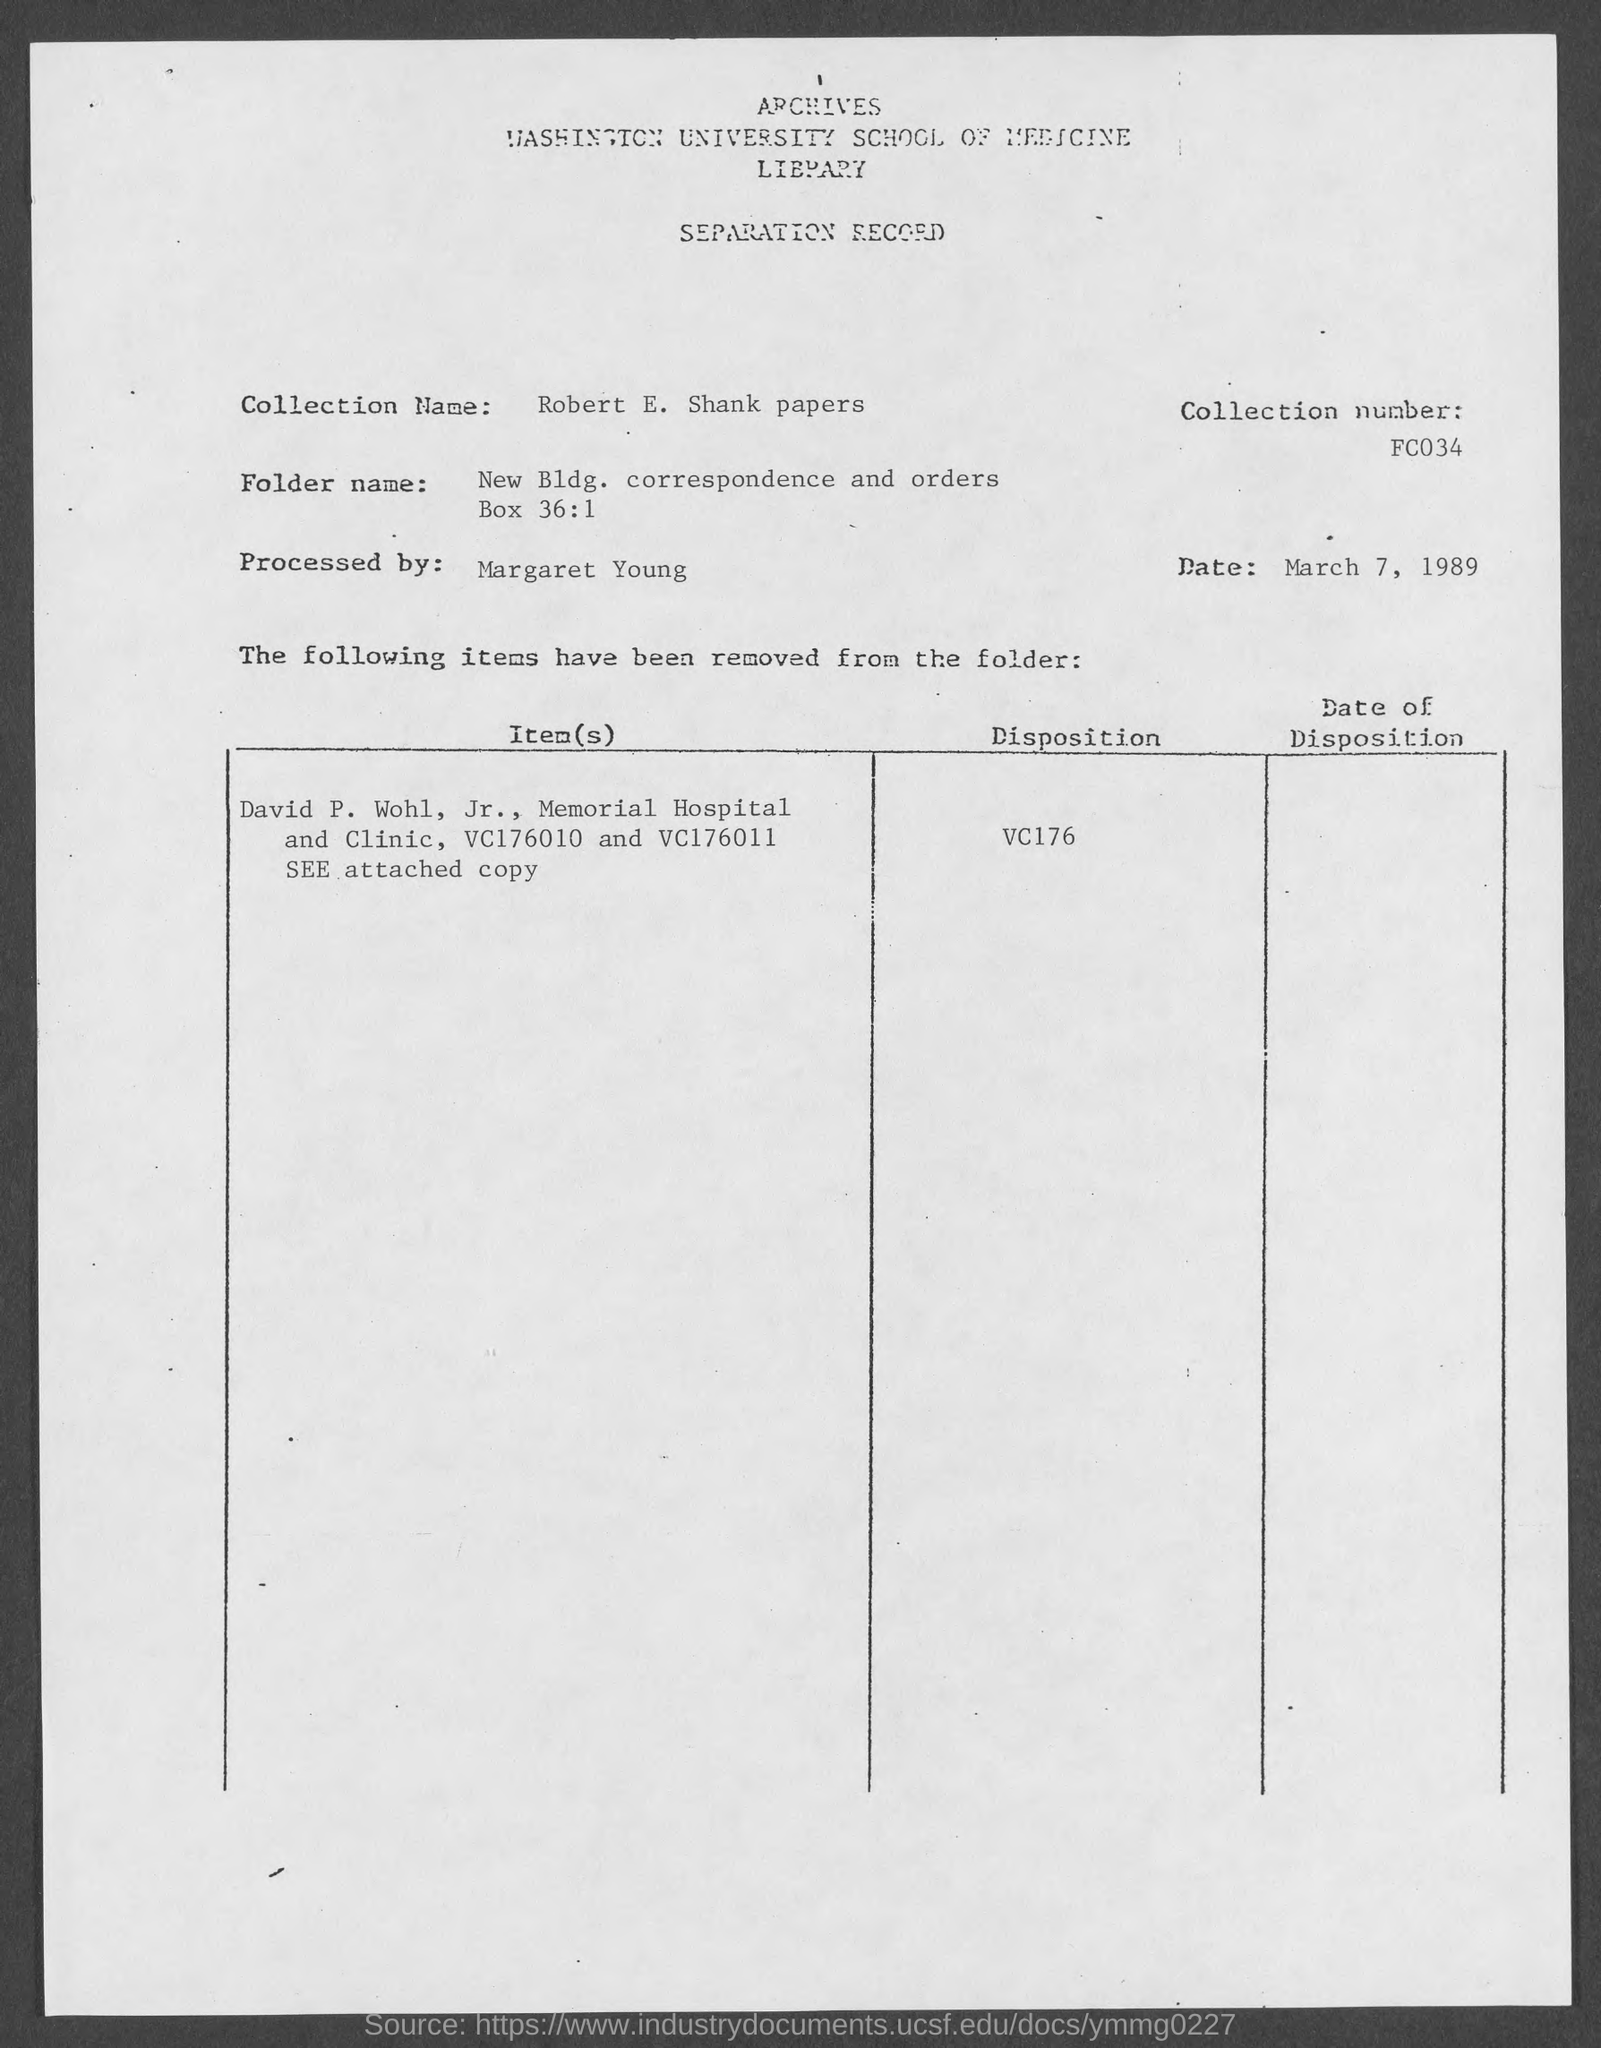What is the collection name given in the separation record?
Keep it short and to the point. Robert E. Shank papers. What is the collection number mentioned in the record?
Provide a succinct answer. FC034. What is the date mentioned in the separation record?
Keep it short and to the point. March 7, 1989. 